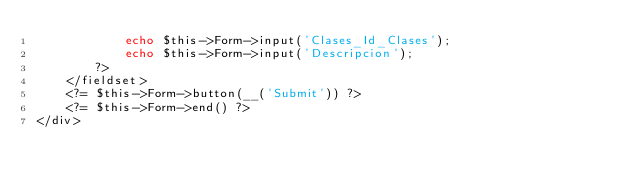<code> <loc_0><loc_0><loc_500><loc_500><_PHP_>            echo $this->Form->input('Clases_Id_Clases');
            echo $this->Form->input('Descripcion');
        ?>
    </fieldset>
    <?= $this->Form->button(__('Submit')) ?>
    <?= $this->Form->end() ?>
</div>
</code> 